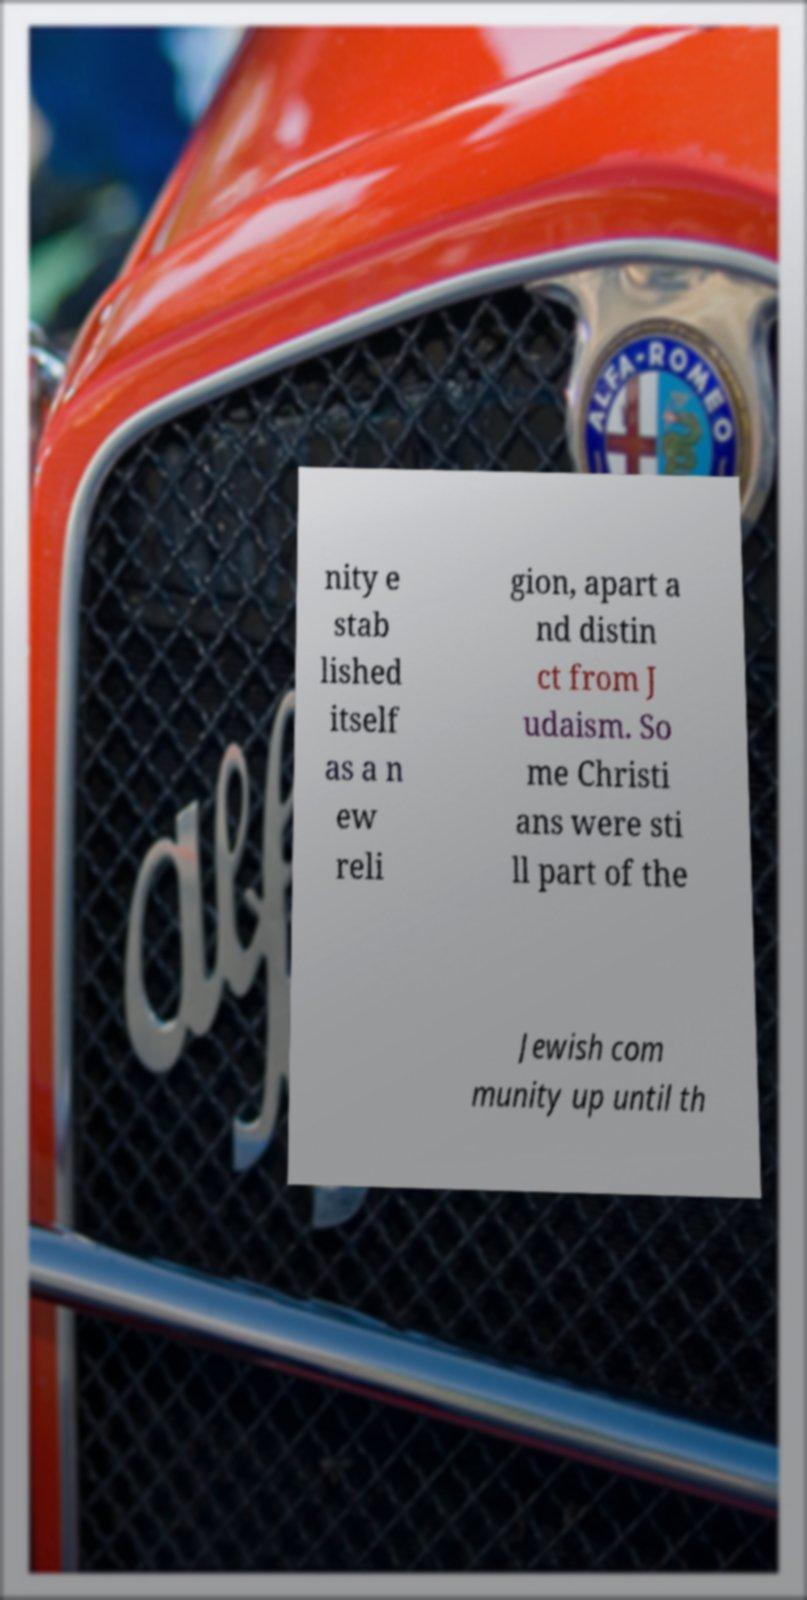For documentation purposes, I need the text within this image transcribed. Could you provide that? nity e stab lished itself as a n ew reli gion, apart a nd distin ct from J udaism. So me Christi ans were sti ll part of the Jewish com munity up until th 